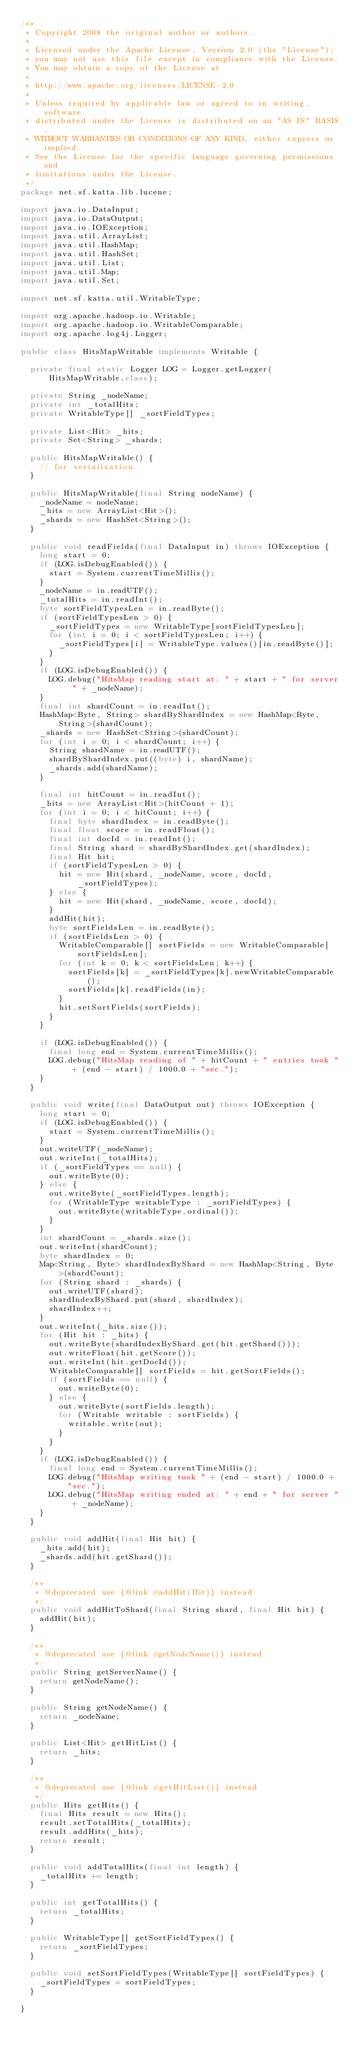Convert code to text. <code><loc_0><loc_0><loc_500><loc_500><_Java_>/**
 * Copyright 2008 the original author or authors.
 *
 * Licensed under the Apache License, Version 2.0 (the "License");
 * you may not use this file except in compliance with the License.
 * You may obtain a copy of the License at
 *
 * http://www.apache.org/licenses/LICENSE-2.0
 *
 * Unless required by applicable law or agreed to in writing, software
 * distributed under the License is distributed on an "AS IS" BASIS,
 * WITHOUT WARRANTIES OR CONDITIONS OF ANY KIND, either express or implied.
 * See the License for the specific language governing permissions and
 * limitations under the License.
 */
package net.sf.katta.lib.lucene;

import java.io.DataInput;
import java.io.DataOutput;
import java.io.IOException;
import java.util.ArrayList;
import java.util.HashMap;
import java.util.HashSet;
import java.util.List;
import java.util.Map;
import java.util.Set;

import net.sf.katta.util.WritableType;

import org.apache.hadoop.io.Writable;
import org.apache.hadoop.io.WritableComparable;
import org.apache.log4j.Logger;

public class HitsMapWritable implements Writable {

  private final static Logger LOG = Logger.getLogger(HitsMapWritable.class);

  private String _nodeName;
  private int _totalHits;
  private WritableType[] _sortFieldTypes;

  private List<Hit> _hits;
  private Set<String> _shards;

  public HitsMapWritable() {
    // for serialization
  }

  public HitsMapWritable(final String nodeName) {
    _nodeName = nodeName;
    _hits = new ArrayList<Hit>();
    _shards = new HashSet<String>();
  }

  public void readFields(final DataInput in) throws IOException {
    long start = 0;
    if (LOG.isDebugEnabled()) {
      start = System.currentTimeMillis();
    }
    _nodeName = in.readUTF();
    _totalHits = in.readInt();
    byte sortFieldTypesLen = in.readByte();
    if (sortFieldTypesLen > 0) {
      _sortFieldTypes = new WritableType[sortFieldTypesLen];
      for (int i = 0; i < sortFieldTypesLen; i++) {
        _sortFieldTypes[i] = WritableType.values()[in.readByte()];
      }
    }
    if (LOG.isDebugEnabled()) {
      LOG.debug("HitsMap reading start at: " + start + " for server " + _nodeName);
    }
    final int shardCount = in.readInt();
    HashMap<Byte, String> shardByShardIndex = new HashMap<Byte, String>(shardCount);
    _shards = new HashSet<String>(shardCount);
    for (int i = 0; i < shardCount; i++) {
      String shardName = in.readUTF();
      shardByShardIndex.put((byte) i, shardName);
      _shards.add(shardName);
    }

    final int hitCount = in.readInt();
    _hits = new ArrayList<Hit>(hitCount + 1);
    for (int i = 0; i < hitCount; i++) {
      final byte shardIndex = in.readByte();
      final float score = in.readFloat();
      final int docId = in.readInt();
      final String shard = shardByShardIndex.get(shardIndex);
      final Hit hit;
      if (sortFieldTypesLen > 0) {
        hit = new Hit(shard, _nodeName, score, docId, _sortFieldTypes);
      } else {
        hit = new Hit(shard, _nodeName, score, docId);
      }
      addHit(hit);
      byte sortFieldsLen = in.readByte();
      if (sortFieldsLen > 0) {
        WritableComparable[] sortFields = new WritableComparable[sortFieldsLen];
        for (int k = 0; k < sortFieldsLen; k++) {
          sortFields[k] = _sortFieldTypes[k].newWritableComparable();
          sortFields[k].readFields(in);
        }
        hit.setSortFields(sortFields);
      }
    }

    if (LOG.isDebugEnabled()) {
      final long end = System.currentTimeMillis();
      LOG.debug("HitsMap reading of " + hitCount + " entries took " + (end - start) / 1000.0 + "sec.");
    }
  }

  public void write(final DataOutput out) throws IOException {
    long start = 0;
    if (LOG.isDebugEnabled()) {
      start = System.currentTimeMillis();
    }
    out.writeUTF(_nodeName);
    out.writeInt(_totalHits);
    if (_sortFieldTypes == null) {
      out.writeByte(0);
    } else {
      out.writeByte(_sortFieldTypes.length);
      for (WritableType writableType : _sortFieldTypes) {
        out.writeByte(writableType.ordinal());
      }
    }
    int shardCount = _shards.size();
    out.writeInt(shardCount);
    byte shardIndex = 0;
    Map<String, Byte> shardIndexByShard = new HashMap<String, Byte>(shardCount);
    for (String shard : _shards) {
      out.writeUTF(shard);
      shardIndexByShard.put(shard, shardIndex);
      shardIndex++;
    }
    out.writeInt(_hits.size());
    for (Hit hit : _hits) {
      out.writeByte(shardIndexByShard.get(hit.getShard()));
      out.writeFloat(hit.getScore());
      out.writeInt(hit.getDocId());
      WritableComparable[] sortFields = hit.getSortFields();
      if (sortFields == null) {
        out.writeByte(0);
      } else {
        out.writeByte(sortFields.length);
        for (Writable writable : sortFields) {
          writable.write(out);
        }
      }
    }
    if (LOG.isDebugEnabled()) {
      final long end = System.currentTimeMillis();
      LOG.debug("HitsMap writing took " + (end - start) / 1000.0 + "sec.");
      LOG.debug("HitsMap writing ended at: " + end + " for server " + _nodeName);
    }
  }

  public void addHit(final Hit hit) {
    _hits.add(hit);
    _shards.add(hit.getShard());
  }

  /**
   * @deprecated use {@link #addHit(Hit)} instead
   */
  public void addHitToShard(final String shard, final Hit hit) {
    addHit(hit);
  }

  /**
   * @deprecated use {@link #getNodeName()} instead
   */
  public String getServerName() {
    return getNodeName();
  }

  public String getNodeName() {
    return _nodeName;
  }

  public List<Hit> getHitList() {
    return _hits;
  }

  /**
   * @deprecated use {@link #getHitList()} instead
   */
  public Hits getHits() {
    final Hits result = new Hits();
    result.setTotalHits(_totalHits);
    result.addHits(_hits);
    return result;
  }

  public void addTotalHits(final int length) {
    _totalHits += length;
  }

  public int getTotalHits() {
    return _totalHits;
  }

  public WritableType[] getSortFieldTypes() {
    return _sortFieldTypes;
  }

  public void setSortFieldTypes(WritableType[] sortFieldTypes) {
    _sortFieldTypes = sortFieldTypes;
  }

}
</code> 